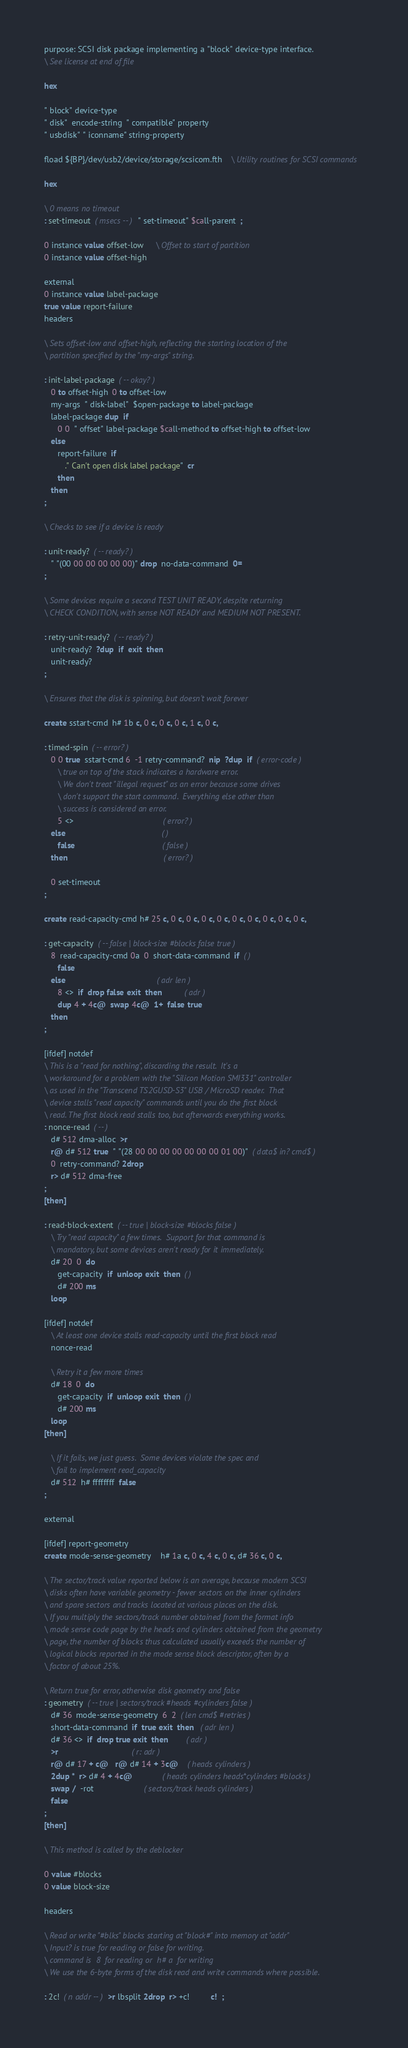<code> <loc_0><loc_0><loc_500><loc_500><_Forth_>purpose: SCSI disk package implementing a "block" device-type interface.
\ See license at end of file

hex

" block" device-type
" disk"  encode-string  " compatible" property
" usbdisk" " iconname" string-property

fload ${BP}/dev/usb2/device/storage/scsicom.fth	\ Utility routines for SCSI commands

hex

\ 0 means no timeout
: set-timeout  ( msecs -- )  " set-timeout" $call-parent  ;

0 instance value offset-low     \ Offset to start of partition
0 instance value offset-high

external
0 instance value label-package
true value report-failure
headers

\ Sets offset-low and offset-high, reflecting the starting location of the
\ partition specified by the "my-args" string.

: init-label-package  ( -- okay? )
   0 to offset-high  0 to offset-low
   my-args  " disk-label"  $open-package to label-package
   label-package dup  if
      0 0  " offset" label-package $call-method to offset-high to offset-low
   else
      report-failure  if
         ." Can't open disk label package"  cr
      then
   then
;

\ Checks to see if a device is ready

: unit-ready?  ( -- ready? )
   " "(00 00 00 00 00 00)" drop  no-data-command  0=
;

\ Some devices require a second TEST UNIT READY, despite returning
\ CHECK CONDITION, with sense NOT READY and MEDIUM NOT PRESENT.

: retry-unit-ready?  ( -- ready? )
   unit-ready?  ?dup  if  exit  then
   unit-ready?
;

\ Ensures that the disk is spinning, but doesn't wait forever

create sstart-cmd  h# 1b c, 0 c, 0 c, 0 c, 1 c, 0 c,

: timed-spin  ( -- error? )
   0 0 true  sstart-cmd 6  -1 retry-command?  nip  ?dup  if  ( error-code )
      \ true on top of the stack indicates a hardware error.
      \ We don't treat "illegal request" as an error because some drives
      \ don't support the start command.  Everything else other than
      \ success is considered an error.
      5 <>                                       ( error? )
   else                                          ( )
      false                                      ( false )
   then                                          ( error? )

   0 set-timeout
;

create read-capacity-cmd h# 25 c, 0 c, 0 c, 0 c, 0 c, 0 c, 0 c, 0 c, 0 c, 0 c, 

: get-capacity  ( -- false | block-size #blocks false true )
   8  read-capacity-cmd 0a  0  short-data-command  if  ( )
      false
   else                                        ( adr len )
      8 <>  if  drop false exit  then          ( adr )
      dup 4 + 4c@  swap 4c@  1+  false true
   then
;

[ifdef] notdef
\ This is a "read for nothing", discarding the result.  It's a
\ workaround for a problem with the "Silicon Motion SMI331" controller
\ as used in the "Transcend TS2GUSD-S3" USB / MicroSD reader.  That
\ device stalls "read capacity" commands until you do the first block
\ read. The first block read stalls too, but afterwards everything works. 
: nonce-read  ( -- )
   d# 512 dma-alloc  >r
   r@ d# 512 true  " "(28 00 00 00 00 00 00 00 01 00)"  ( data$ in? cmd$ )
   0  retry-command? 2drop
   r> d# 512 dma-free
;
[then]

: read-block-extent  ( -- true | block-size #blocks false )
   \ Try "read capacity" a few times.  Support for that command is
   \ mandatory, but some devices aren't ready for it immediately.
   d# 20  0  do
      get-capacity  if  unloop exit  then  ( )
      d# 200 ms
   loop

[ifdef] notdef
   \ At least one device stalls read-capacity until the first block read
   nonce-read

   \ Retry it a few more times
   d# 18  0  do
      get-capacity  if  unloop exit  then  ( )
      d# 200 ms
   loop
[then]

   \ If it fails, we just guess.  Some devices violate the spec and
   \ fail to implement read_capacity
   d# 512  h# ffffffff  false
;

external

[ifdef] report-geometry
create mode-sense-geometry    h# 1a c, 0 c, 4 c, 0 c, d# 36 c, 0 c,

\ The sector/track value reported below is an average, because modern SCSI
\ disks often have variable geometry - fewer sectors on the inner cylinders
\ and spare sectors and tracks located at various places on the disk.
\ If you multiply the sectors/track number obtained from the format info
\ mode sense code page by the heads and cylinders obtained from the geometry
\ page, the number of blocks thus calculated usually exceeds the number of
\ logical blocks reported in the mode sense block descriptor, often by a
\ factor of about 25%.

\ Return true for error, otherwise disk geometry and false
: geometry  ( -- true | sectors/track #heads #cylinders false )
   d# 36  mode-sense-geometry  6  2  ( len cmd$ #retries )
   short-data-command  if  true exit  then   ( adr len )
   d# 36 <>  if  drop true exit  then        ( adr )
   >r                                ( r: adr )
   r@ d# 17 + c@   r@ d# 14 + 3c@    ( heads cylinders )
   2dup *  r> d# 4 + 4c@             ( heads cylinders heads*cylinders #blocks )
   swap /  -rot                      ( sectors/track heads cylinders )
   false   
;
[then]

\ This method is called by the deblocker

0 value #blocks
0 value block-size

headers

\ Read or write "#blks" blocks starting at "block#" into memory at "addr"
\ Input? is true for reading or false for writing.
\ command is  8  for reading or  h# a  for writing
\ We use the 6-byte forms of the disk read and write commands where possible.

: 2c!  ( n addr -- )  >r lbsplit 2drop  r> +c!         c!  ;</code> 